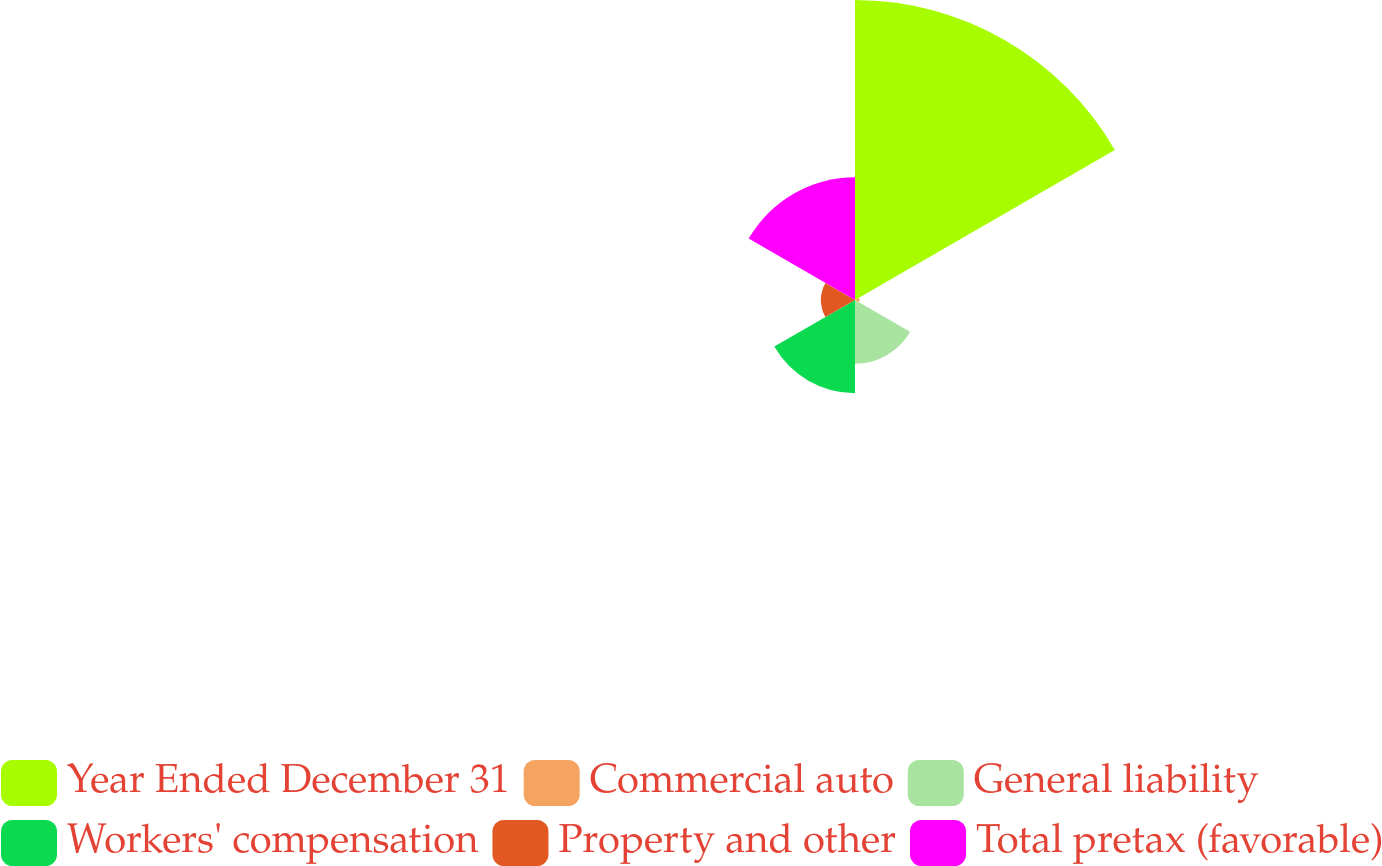<chart> <loc_0><loc_0><loc_500><loc_500><pie_chart><fcel>Year Ended December 31<fcel>Commercial auto<fcel>General liability<fcel>Workers' compensation<fcel>Property and other<fcel>Total pretax (favorable)<nl><fcel>48.51%<fcel>0.75%<fcel>10.3%<fcel>15.07%<fcel>5.52%<fcel>19.85%<nl></chart> 